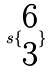Convert formula to latex. <formula><loc_0><loc_0><loc_500><loc_500>s \{ \begin{matrix} 6 \\ 3 \end{matrix} \}</formula> 